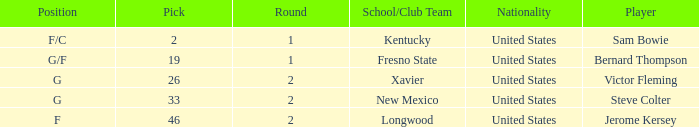What is the highest Pick, when Position is "G/F"? 19.0. 